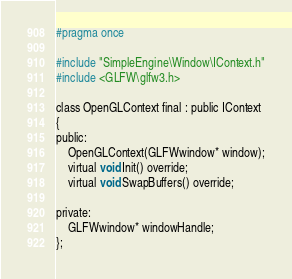Convert code to text. <code><loc_0><loc_0><loc_500><loc_500><_C_>#pragma once

#include "SimpleEngine\Window\IContext.h"
#include <GLFW\glfw3.h>

class OpenGLContext final : public IContext
{
public:
	OpenGLContext(GLFWwindow* window);
	virtual void Init() override;
	virtual void SwapBuffers() override;

private:
	GLFWwindow* windowHandle;
};</code> 